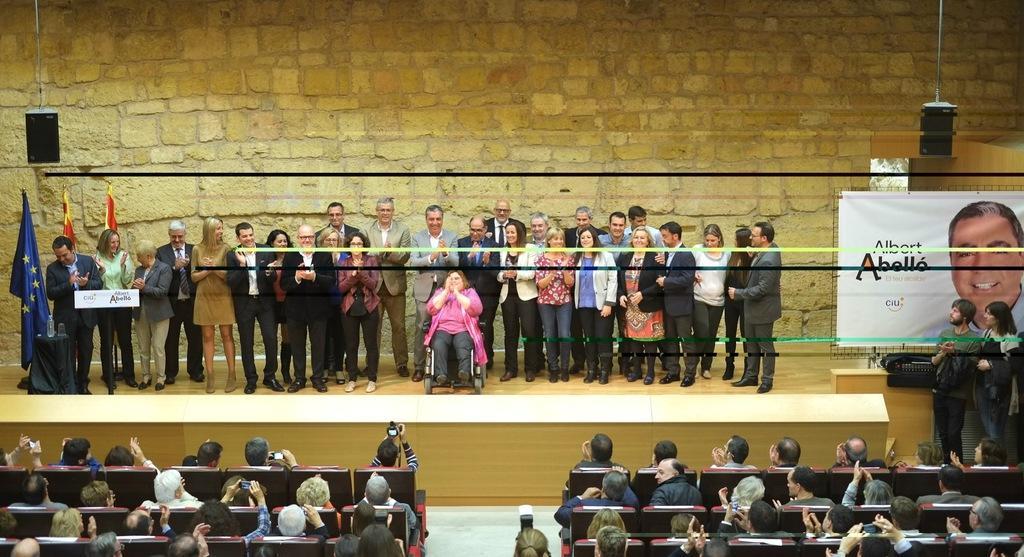How would you summarize this image in a sentence or two? In the background we can see the wall, flags, hoarding, few devices and poles. We can see people standing on a platform and we can see a woman sitting on a chair. Near to the platform we can see the people sitting on the chairs and among them few are holding devices. On the right side of the picture we can see a man and a woman standing. 